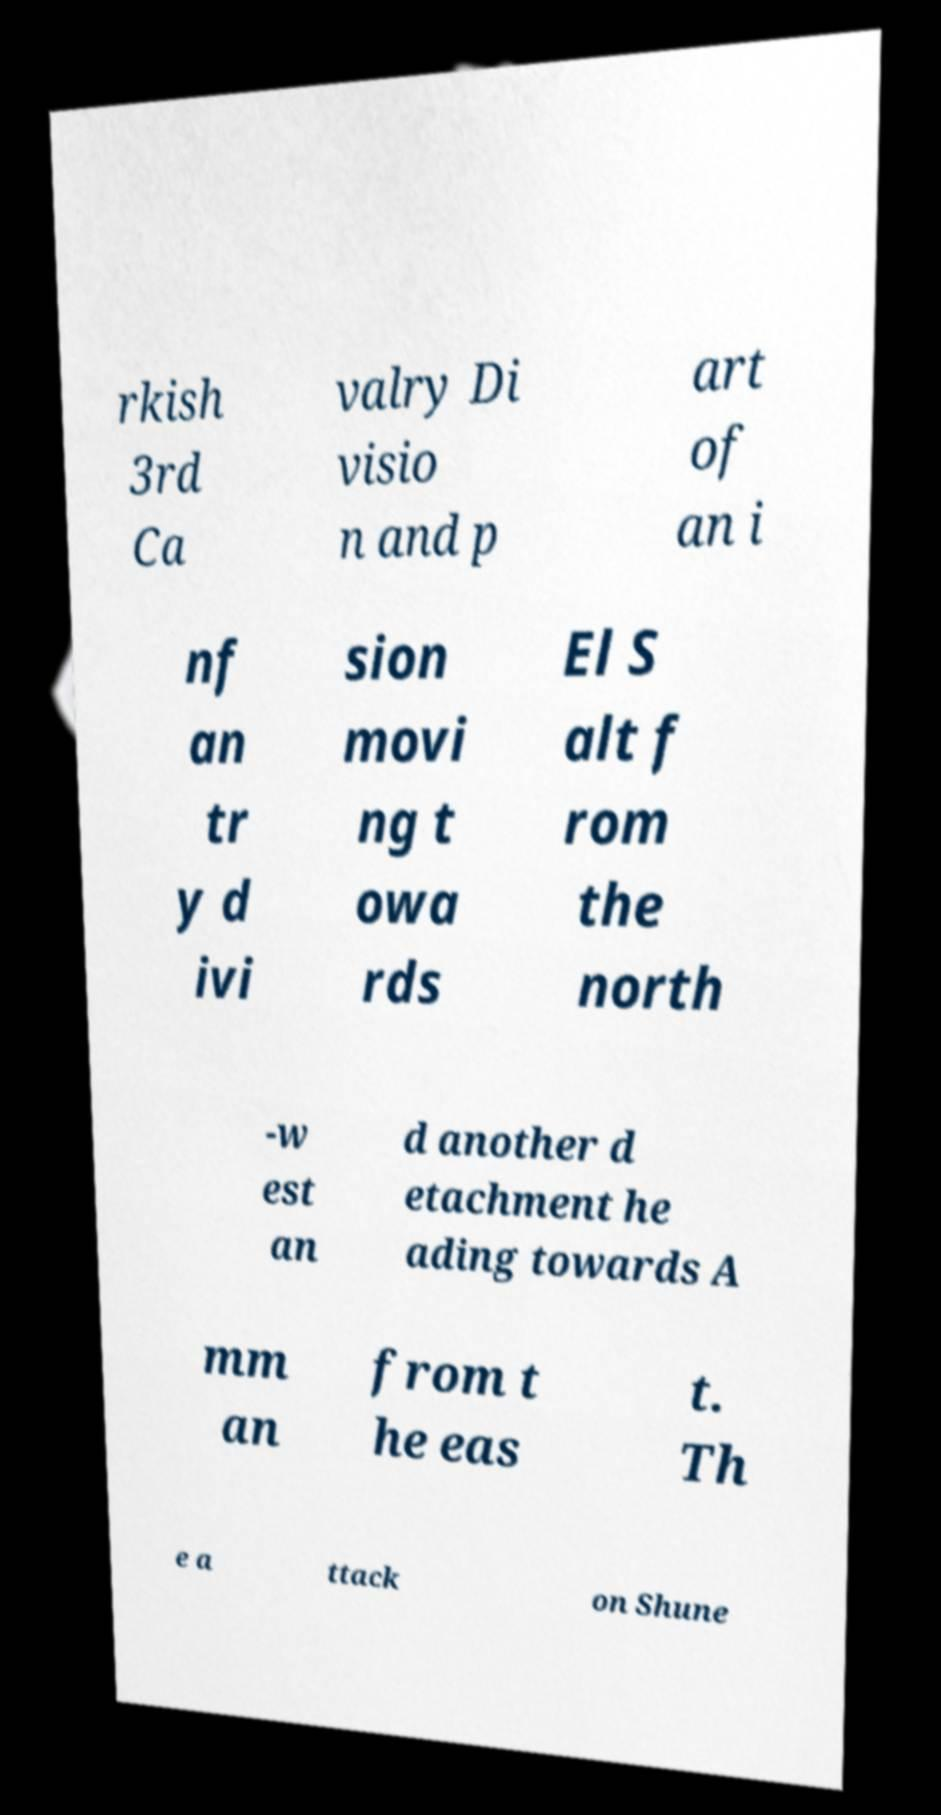Please read and relay the text visible in this image. What does it say? rkish 3rd Ca valry Di visio n and p art of an i nf an tr y d ivi sion movi ng t owa rds El S alt f rom the north -w est an d another d etachment he ading towards A mm an from t he eas t. Th e a ttack on Shune 